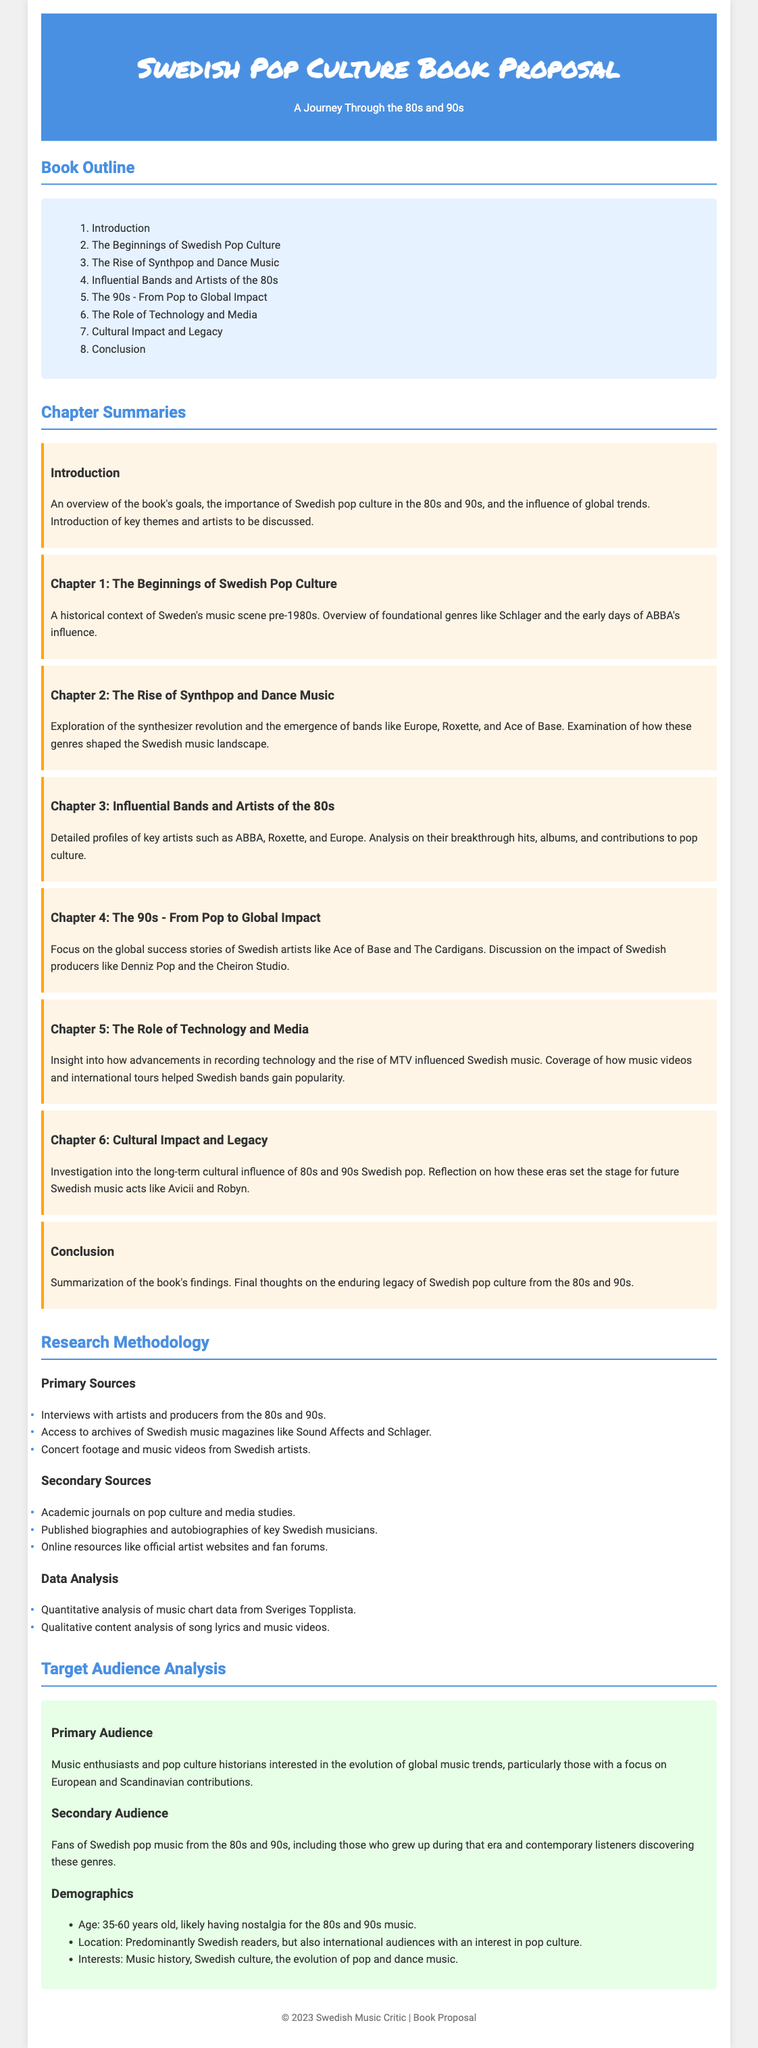What is the title of the book proposal? The title of the book proposal is presented at the header section of the document.
Answer: Swedish Pop Culture Book Proposal How many chapters are in the book outline? The book outline includes a list of chapters, which can be counted.
Answer: 8 chapters Which influential band is mentioned in Chapter 3? Chapter 3 details profiles of key artists from the 80s, stating specific bands.
Answer: ABBA What was the primary source of data analysis mentioned? The methodology section specifies sources for primary data analysis.
Answer: Interviews with artists and producers What age range is identified as the primary target audience? The target audience analysis provides demographic details, including age range.
Answer: 35-60 years old What genre is emphasized in Chapter 2? Chapter 2 focuses on the rise of a particular music genre during the defined period.
Answer: Synthpop and Dance Music What is one type of secondary source listed in the document? The methodology mentions specific types of secondary sources for research.
Answer: Academic journals What is the main theme of the introduction chapter? The introduction chapter outlines the primary focus of the book's content.
Answer: Overview of the book's goals 